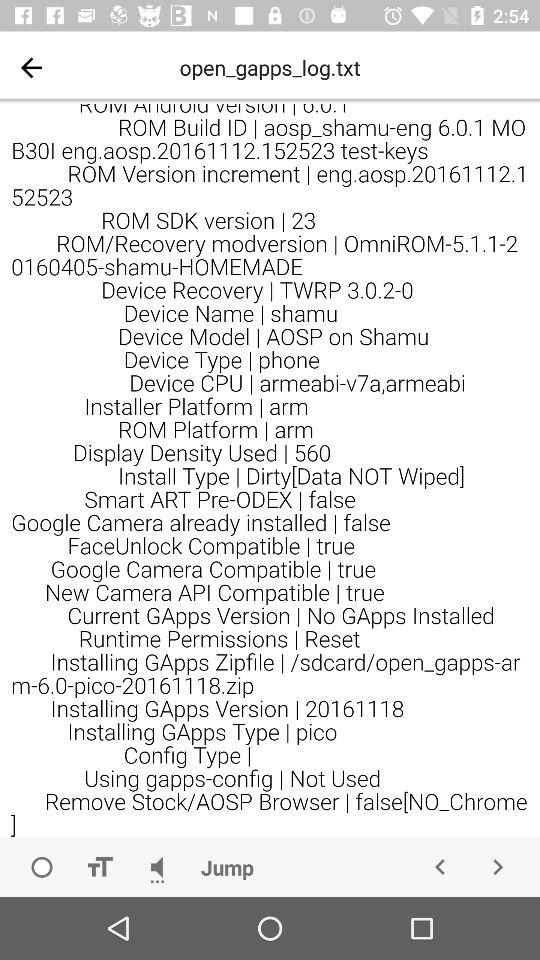What is the ROM Build ID? The ROM Build ID is "aosp_shamu-eng 6.0.1 MO B301 eng.aosp.20161112.152523 test-keys". 